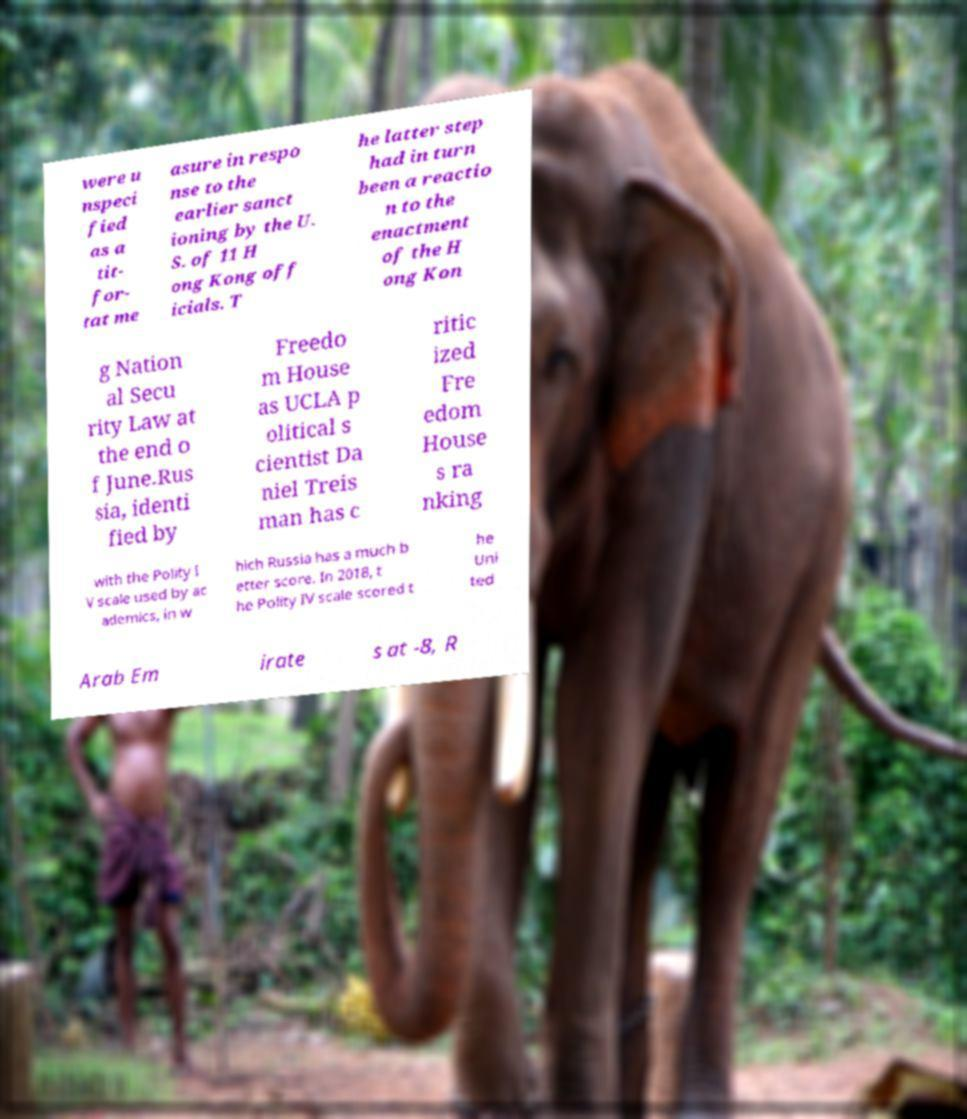Please read and relay the text visible in this image. What does it say? were u nspeci fied as a tit- for- tat me asure in respo nse to the earlier sanct ioning by the U. S. of 11 H ong Kong off icials. T he latter step had in turn been a reactio n to the enactment of the H ong Kon g Nation al Secu rity Law at the end o f June.Rus sia, identi fied by Freedo m House as UCLA p olitical s cientist Da niel Treis man has c ritic ized Fre edom House s ra nking with the Polity I V scale used by ac ademics, in w hich Russia has a much b etter score. In 2018, t he Polity IV scale scored t he Uni ted Arab Em irate s at -8, R 